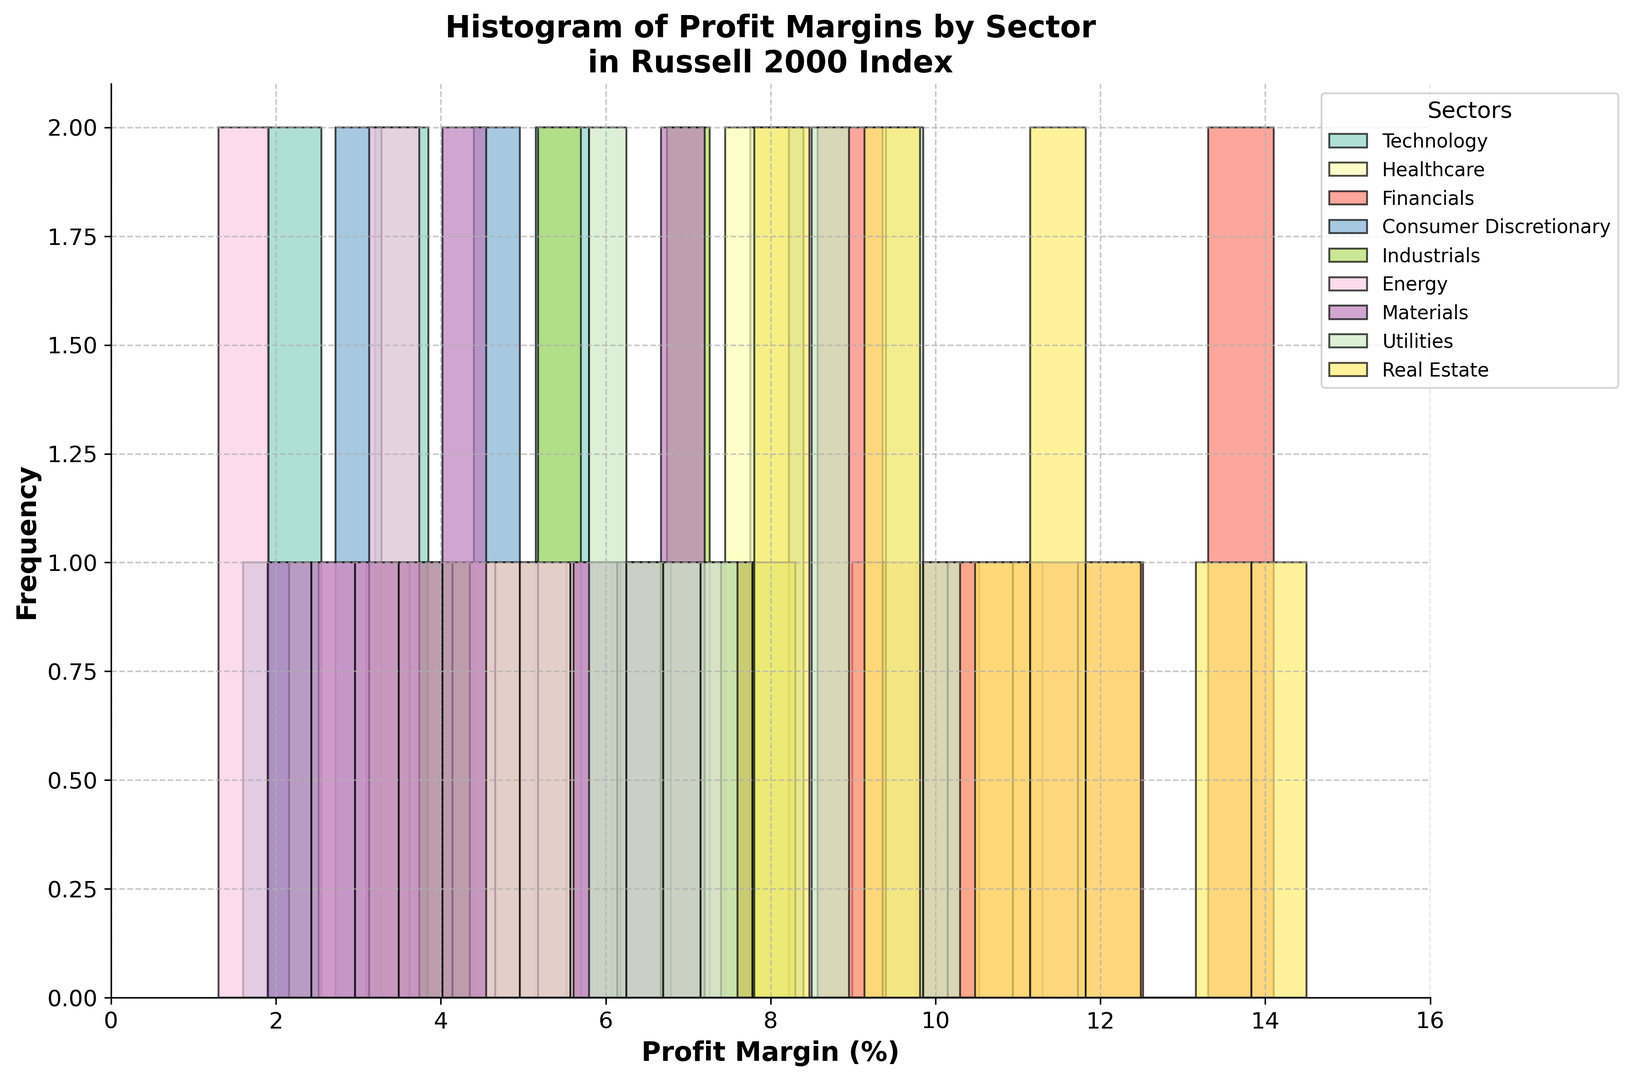How many companies in the Healthcare sector have a profit margin above 10%? To answer this, observe the number of bars representing the frequency of companies in the Healthcare sector with a profit margin above 10%. There are two bars in the Healthcare sector histogram that meet this criterion: one bar between 10 and 11% and one bar between 11 and 12%.
Answer: 2 Which sector has the highest peak in its histogram? Look at the tallest bar in the histograms for each sector. The Utilities sector has the highest peak, indicating that it has the most companies within the same profit margin range.
Answer: Utilities What's the difference in the frequency of companies with a profit margin between 6% to 8% in the Technology and Industrials sectors? Identify the bars representing the 6% to 8% profit margin range for both Technology and Industrials sectors. Calculate the frequency by subtracting the height of bars in these sectors. For Technology, the frequency is around 2 companies and for Industrials, it is about 2 to 3 companies. The difference is approximately 0.
Answer: 0 Compare the median profit margin of the Energy and Consumer Discretionary sectors. Which one is higher? To estimate the median visually, look for the profit margin at the midpoint in the distribution for each sector. The medians for Energy and Consumer Discretionary appear around 4-5% and 4%, respectively.
Answer: Energy In which sector do most companies have a profit margin between 0% to 4%? Compare the frequency of bars in the 0% to 4% profit margin range across all sectors. The Energy sector shows a higher concentration of companies in this range.
Answer: Energy What is the range of profit margins in the Financials sector? Identify the minimum and maximum profit margins in the Financials sector from the histogram. The minimum value is around 6% and the maximum is around 14%. The range is 14% - 6% = 8%.
Answer: 8% How does the spread of profit margins in the Real Estate sector compare to the spread in the Materials sector? Observe the range of values (spread) in the Real Estate and Materials sectors. The Real Estate sector ranges from 7.8% to 14.5% and the Materials sector ranges from 1.9% to 7.2%. The Real Estate sector has a wider spread.
Answer: Real Estate What percentage of sectors show a mode profit margin between 6% and 8%? Calculate the total number of sectors and identify how many have the highest frequency mode in the profit margin between 6% and 8%. Here, 5 sectors have their mode between 6% and 8% out of 8 sectors. Thus, 5/8 * 100 = 62.5%.
Answer: 62.5% Which sector has the lowest minimum profit margin, and what is the value? Identify the sector with the bar starting closest to 0%. The Energy sector has the lowest minimum profit margin at 1.3%.
Answer: Energy, 1.3% How does the distribution of profit margins differ between the Technology and Real Estate sectors? Compare the shapes of histograms: Technology shows more spread between 1.9% and 8.4%, indicating a more uniform distribution. Real Estate is concentrated between 7.8% and 14.5%, indicating companies cluster around higher profit margins.
Answer: Technology is more spread out, Real Estate is more concentrated at higher margins 